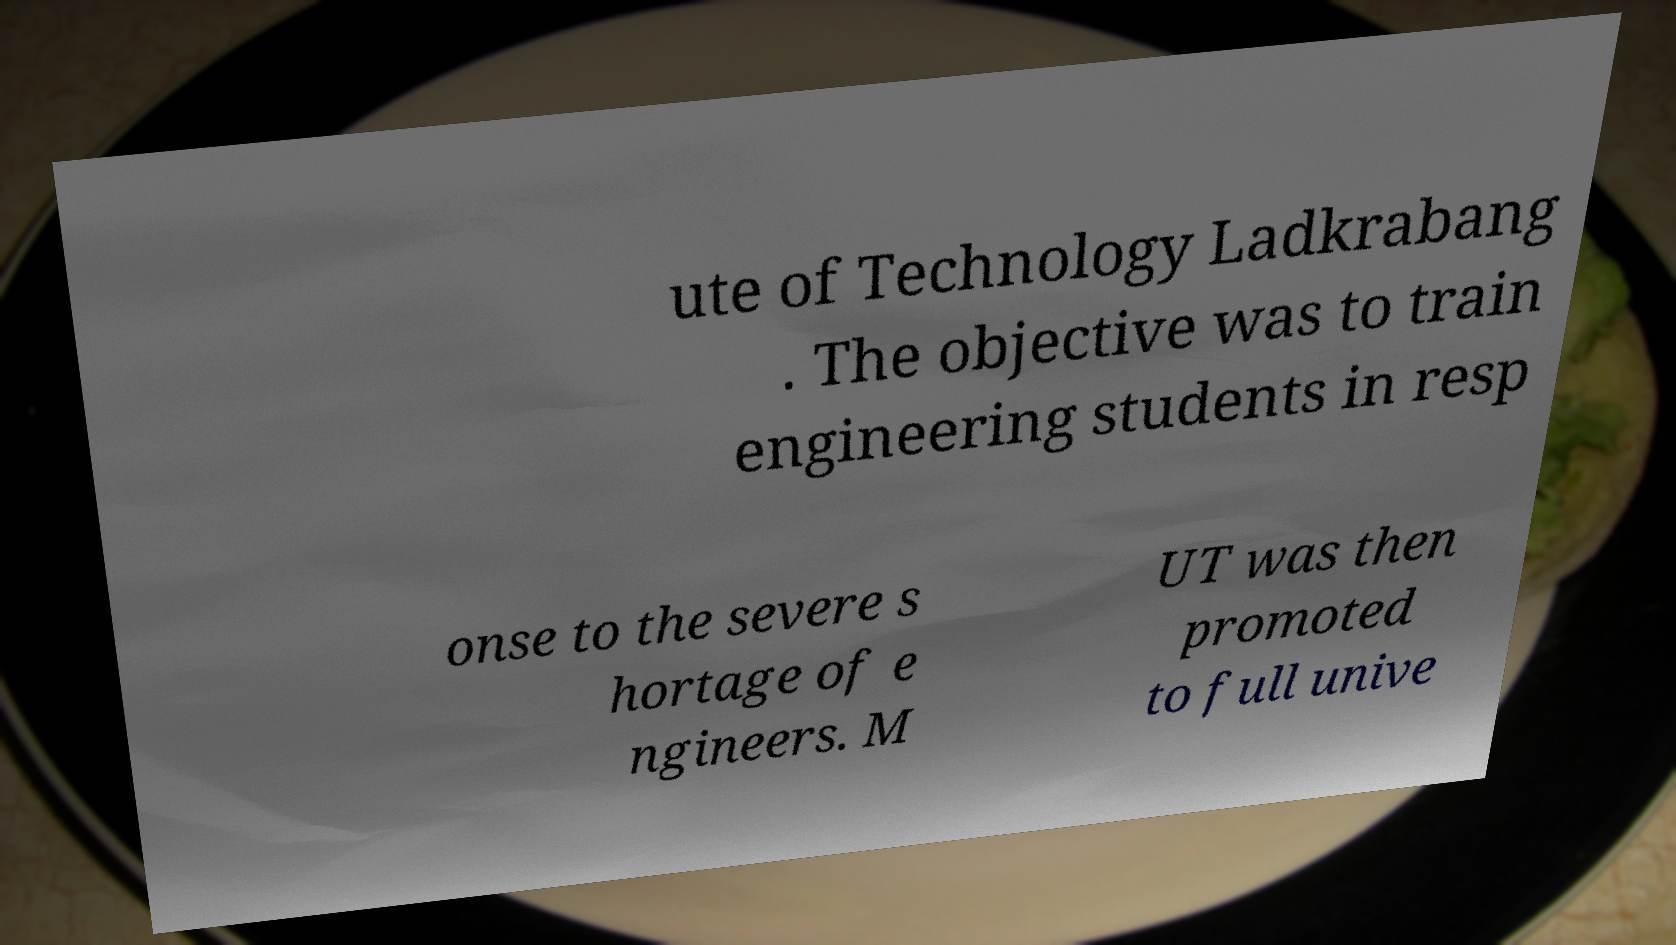Please read and relay the text visible in this image. What does it say? ute of Technology Ladkrabang . The objective was to train engineering students in resp onse to the severe s hortage of e ngineers. M UT was then promoted to full unive 